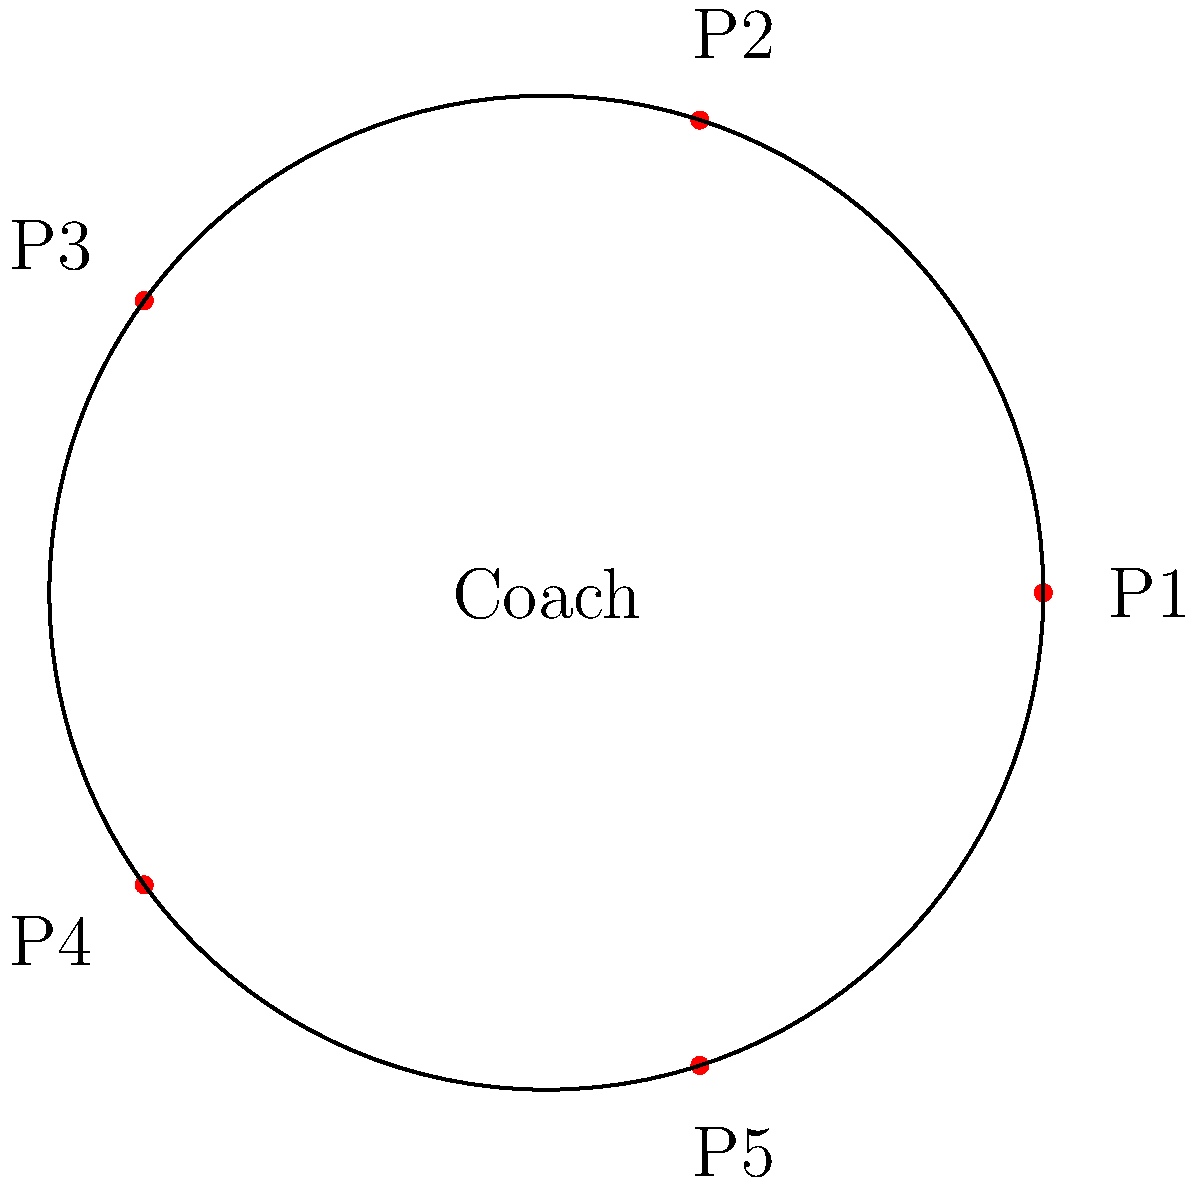In a basketball game, you have a rotation of 5 players (P1, P2, P3, P4, P5) as shown in the diagram. If you substitute one player at a time in a clockwise direction, how many substitutions are needed before the lineup returns to its original configuration? Let's approach this step-by-step:

1) First, we need to understand what a cycle means in this context. A cycle is completed when we return to the original configuration after a series of substitutions.

2) In each substitution, we replace one player with the next in the clockwise direction. This creates a cyclic group of order 5.

3) To return to the original configuration, each player must move through all 5 positions:
   - P1 moves to P2's position, then P3's, then P4's, then P5's, and finally back to P1's.
   - The same is true for all other players.

4) This means that each player must make 5 moves to return to their original position.

5) Since there are 5 players, and each needs to make 5 moves, the total number of substitutions is:

   $$ 5 \times 5 = 25 $$

6) This is consistent with the properties of cyclic groups. In a cyclic group of order n, the identity element (in this case, the original configuration) is reached after n iterations of the generator (in this case, one clockwise substitution).

Therefore, it takes 25 substitutions for the lineup to return to its original configuration.
Answer: 25 substitutions 